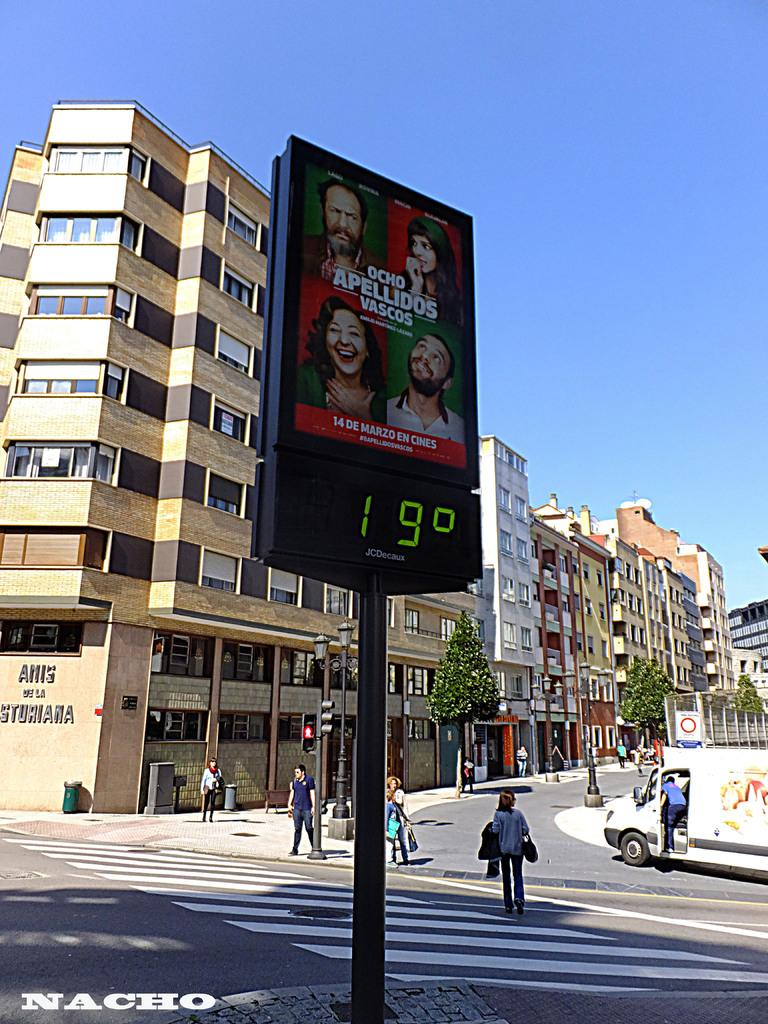<image>
Render a clear and concise summary of the photo. According to a sign above the street it is 19 degrees outside. 